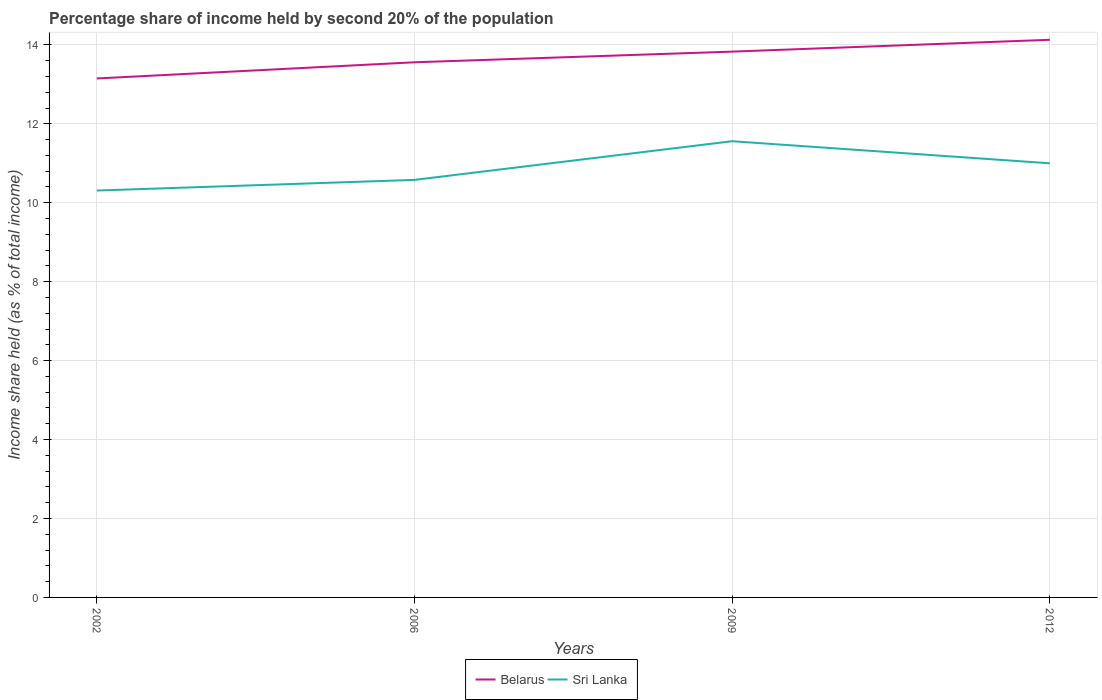How many different coloured lines are there?
Make the answer very short. 2. Across all years, what is the maximum share of income held by second 20% of the population in Sri Lanka?
Provide a succinct answer. 10.31. In which year was the share of income held by second 20% of the population in Belarus maximum?
Offer a terse response. 2002. What is the total share of income held by second 20% of the population in Sri Lanka in the graph?
Your response must be concise. -0.98. What is the difference between the highest and the second highest share of income held by second 20% of the population in Belarus?
Ensure brevity in your answer.  0.98. How many lines are there?
Your answer should be very brief. 2. What is the difference between two consecutive major ticks on the Y-axis?
Offer a terse response. 2. Are the values on the major ticks of Y-axis written in scientific E-notation?
Keep it short and to the point. No. Does the graph contain grids?
Ensure brevity in your answer.  Yes. How are the legend labels stacked?
Make the answer very short. Horizontal. What is the title of the graph?
Your answer should be very brief. Percentage share of income held by second 20% of the population. What is the label or title of the X-axis?
Your response must be concise. Years. What is the label or title of the Y-axis?
Your response must be concise. Income share held (as % of total income). What is the Income share held (as % of total income) in Belarus in 2002?
Give a very brief answer. 13.15. What is the Income share held (as % of total income) in Sri Lanka in 2002?
Your response must be concise. 10.31. What is the Income share held (as % of total income) in Belarus in 2006?
Your answer should be very brief. 13.56. What is the Income share held (as % of total income) of Sri Lanka in 2006?
Offer a terse response. 10.58. What is the Income share held (as % of total income) in Belarus in 2009?
Provide a short and direct response. 13.83. What is the Income share held (as % of total income) of Sri Lanka in 2009?
Provide a short and direct response. 11.56. What is the Income share held (as % of total income) of Belarus in 2012?
Your answer should be very brief. 14.13. Across all years, what is the maximum Income share held (as % of total income) in Belarus?
Make the answer very short. 14.13. Across all years, what is the maximum Income share held (as % of total income) in Sri Lanka?
Your response must be concise. 11.56. Across all years, what is the minimum Income share held (as % of total income) in Belarus?
Give a very brief answer. 13.15. Across all years, what is the minimum Income share held (as % of total income) of Sri Lanka?
Your answer should be compact. 10.31. What is the total Income share held (as % of total income) of Belarus in the graph?
Keep it short and to the point. 54.67. What is the total Income share held (as % of total income) in Sri Lanka in the graph?
Provide a short and direct response. 43.45. What is the difference between the Income share held (as % of total income) of Belarus in 2002 and that in 2006?
Provide a succinct answer. -0.41. What is the difference between the Income share held (as % of total income) in Sri Lanka in 2002 and that in 2006?
Offer a terse response. -0.27. What is the difference between the Income share held (as % of total income) in Belarus in 2002 and that in 2009?
Ensure brevity in your answer.  -0.68. What is the difference between the Income share held (as % of total income) of Sri Lanka in 2002 and that in 2009?
Make the answer very short. -1.25. What is the difference between the Income share held (as % of total income) in Belarus in 2002 and that in 2012?
Offer a terse response. -0.98. What is the difference between the Income share held (as % of total income) of Sri Lanka in 2002 and that in 2012?
Your answer should be very brief. -0.69. What is the difference between the Income share held (as % of total income) in Belarus in 2006 and that in 2009?
Offer a very short reply. -0.27. What is the difference between the Income share held (as % of total income) of Sri Lanka in 2006 and that in 2009?
Offer a very short reply. -0.98. What is the difference between the Income share held (as % of total income) in Belarus in 2006 and that in 2012?
Your answer should be very brief. -0.57. What is the difference between the Income share held (as % of total income) in Sri Lanka in 2006 and that in 2012?
Provide a short and direct response. -0.42. What is the difference between the Income share held (as % of total income) in Belarus in 2009 and that in 2012?
Offer a very short reply. -0.3. What is the difference between the Income share held (as % of total income) of Sri Lanka in 2009 and that in 2012?
Ensure brevity in your answer.  0.56. What is the difference between the Income share held (as % of total income) in Belarus in 2002 and the Income share held (as % of total income) in Sri Lanka in 2006?
Provide a short and direct response. 2.57. What is the difference between the Income share held (as % of total income) in Belarus in 2002 and the Income share held (as % of total income) in Sri Lanka in 2009?
Keep it short and to the point. 1.59. What is the difference between the Income share held (as % of total income) in Belarus in 2002 and the Income share held (as % of total income) in Sri Lanka in 2012?
Your response must be concise. 2.15. What is the difference between the Income share held (as % of total income) of Belarus in 2006 and the Income share held (as % of total income) of Sri Lanka in 2009?
Give a very brief answer. 2. What is the difference between the Income share held (as % of total income) in Belarus in 2006 and the Income share held (as % of total income) in Sri Lanka in 2012?
Your answer should be compact. 2.56. What is the difference between the Income share held (as % of total income) of Belarus in 2009 and the Income share held (as % of total income) of Sri Lanka in 2012?
Offer a terse response. 2.83. What is the average Income share held (as % of total income) of Belarus per year?
Ensure brevity in your answer.  13.67. What is the average Income share held (as % of total income) of Sri Lanka per year?
Your response must be concise. 10.86. In the year 2002, what is the difference between the Income share held (as % of total income) in Belarus and Income share held (as % of total income) in Sri Lanka?
Offer a terse response. 2.84. In the year 2006, what is the difference between the Income share held (as % of total income) in Belarus and Income share held (as % of total income) in Sri Lanka?
Your answer should be very brief. 2.98. In the year 2009, what is the difference between the Income share held (as % of total income) in Belarus and Income share held (as % of total income) in Sri Lanka?
Offer a very short reply. 2.27. In the year 2012, what is the difference between the Income share held (as % of total income) of Belarus and Income share held (as % of total income) of Sri Lanka?
Your answer should be compact. 3.13. What is the ratio of the Income share held (as % of total income) of Belarus in 2002 to that in 2006?
Keep it short and to the point. 0.97. What is the ratio of the Income share held (as % of total income) of Sri Lanka in 2002 to that in 2006?
Give a very brief answer. 0.97. What is the ratio of the Income share held (as % of total income) of Belarus in 2002 to that in 2009?
Give a very brief answer. 0.95. What is the ratio of the Income share held (as % of total income) in Sri Lanka in 2002 to that in 2009?
Keep it short and to the point. 0.89. What is the ratio of the Income share held (as % of total income) of Belarus in 2002 to that in 2012?
Keep it short and to the point. 0.93. What is the ratio of the Income share held (as % of total income) of Sri Lanka in 2002 to that in 2012?
Your response must be concise. 0.94. What is the ratio of the Income share held (as % of total income) of Belarus in 2006 to that in 2009?
Offer a very short reply. 0.98. What is the ratio of the Income share held (as % of total income) in Sri Lanka in 2006 to that in 2009?
Your answer should be compact. 0.92. What is the ratio of the Income share held (as % of total income) in Belarus in 2006 to that in 2012?
Offer a terse response. 0.96. What is the ratio of the Income share held (as % of total income) of Sri Lanka in 2006 to that in 2012?
Your answer should be very brief. 0.96. What is the ratio of the Income share held (as % of total income) in Belarus in 2009 to that in 2012?
Make the answer very short. 0.98. What is the ratio of the Income share held (as % of total income) in Sri Lanka in 2009 to that in 2012?
Keep it short and to the point. 1.05. What is the difference between the highest and the second highest Income share held (as % of total income) of Sri Lanka?
Ensure brevity in your answer.  0.56. What is the difference between the highest and the lowest Income share held (as % of total income) of Belarus?
Provide a short and direct response. 0.98. What is the difference between the highest and the lowest Income share held (as % of total income) in Sri Lanka?
Your answer should be very brief. 1.25. 